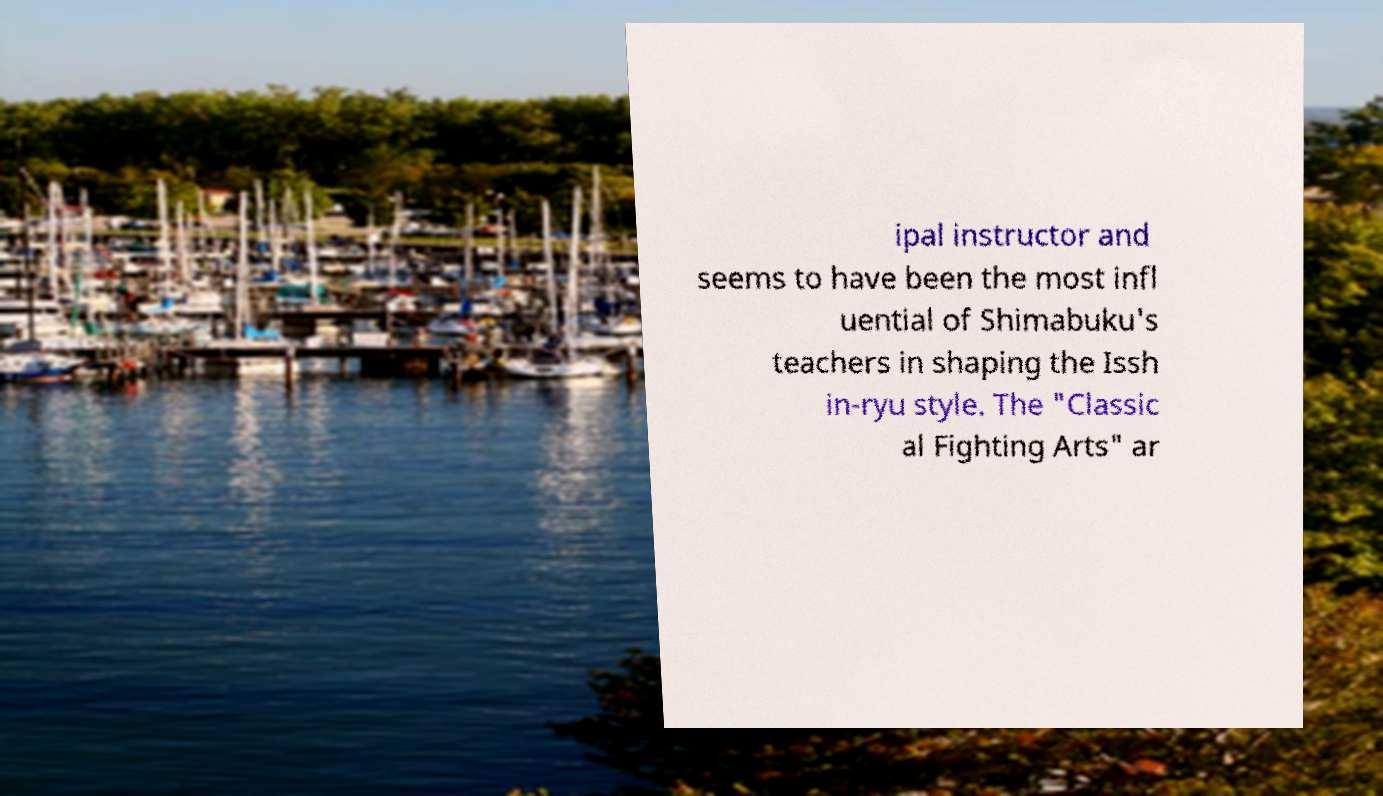Could you extract and type out the text from this image? ipal instructor and seems to have been the most infl uential of Shimabuku's teachers in shaping the Issh in-ryu style. The "Classic al Fighting Arts" ar 